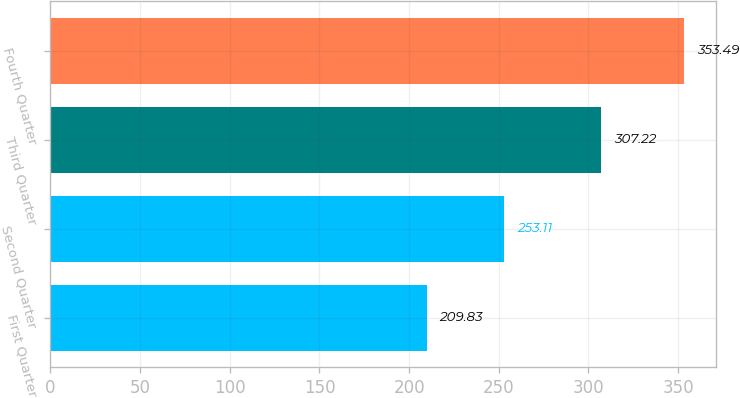Convert chart to OTSL. <chart><loc_0><loc_0><loc_500><loc_500><bar_chart><fcel>First Quarter<fcel>Second Quarter<fcel>Third Quarter<fcel>Fourth Quarter<nl><fcel>209.83<fcel>253.11<fcel>307.22<fcel>353.49<nl></chart> 